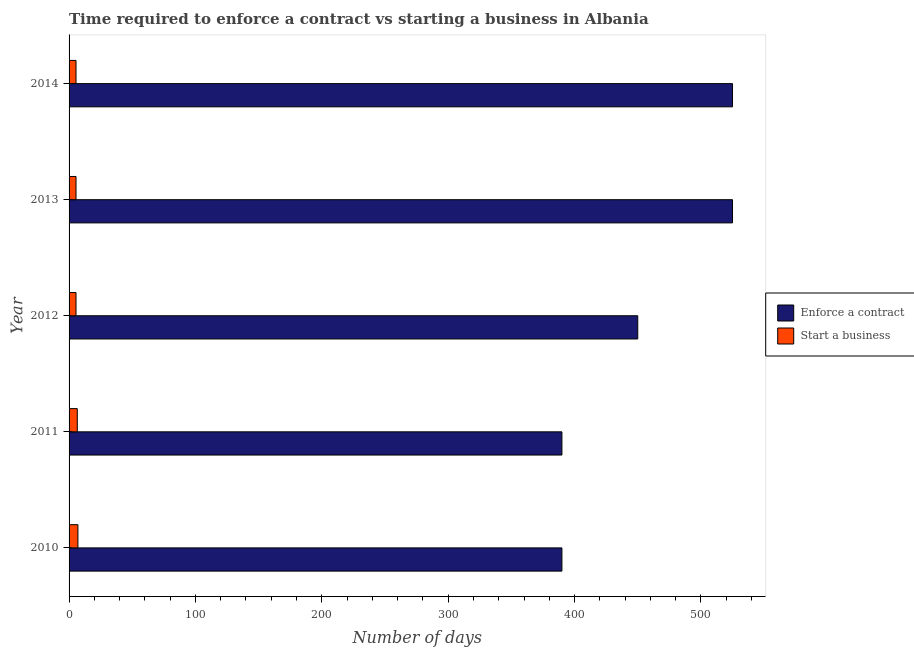How many groups of bars are there?
Provide a short and direct response. 5. Are the number of bars on each tick of the Y-axis equal?
Your response must be concise. Yes. How many bars are there on the 4th tick from the bottom?
Give a very brief answer. 2. In how many cases, is the number of bars for a given year not equal to the number of legend labels?
Your answer should be compact. 0. What is the number of days to enforece a contract in 2011?
Your response must be concise. 390. Across all years, what is the maximum number of days to enforece a contract?
Your answer should be very brief. 525. Across all years, what is the minimum number of days to enforece a contract?
Make the answer very short. 390. In which year was the number of days to enforece a contract maximum?
Offer a very short reply. 2013. What is the total number of days to enforece a contract in the graph?
Ensure brevity in your answer.  2280. What is the difference between the number of days to start a business in 2012 and that in 2014?
Keep it short and to the point. 0. What is the difference between the number of days to enforece a contract in 2010 and the number of days to start a business in 2012?
Keep it short and to the point. 384.5. What is the average number of days to enforece a contract per year?
Ensure brevity in your answer.  456. In the year 2013, what is the difference between the number of days to start a business and number of days to enforece a contract?
Give a very brief answer. -519.5. What is the ratio of the number of days to enforece a contract in 2011 to that in 2013?
Give a very brief answer. 0.74. Is the number of days to enforece a contract in 2010 less than that in 2014?
Your answer should be compact. Yes. Is the difference between the number of days to enforece a contract in 2010 and 2012 greater than the difference between the number of days to start a business in 2010 and 2012?
Provide a succinct answer. No. What is the difference between the highest and the lowest number of days to start a business?
Provide a short and direct response. 1.5. What does the 2nd bar from the top in 2012 represents?
Give a very brief answer. Enforce a contract. What does the 2nd bar from the bottom in 2010 represents?
Make the answer very short. Start a business. Are all the bars in the graph horizontal?
Make the answer very short. Yes. How many years are there in the graph?
Ensure brevity in your answer.  5. Does the graph contain grids?
Provide a succinct answer. No. How many legend labels are there?
Ensure brevity in your answer.  2. How are the legend labels stacked?
Offer a very short reply. Vertical. What is the title of the graph?
Give a very brief answer. Time required to enforce a contract vs starting a business in Albania. Does "Working capital" appear as one of the legend labels in the graph?
Ensure brevity in your answer.  No. What is the label or title of the X-axis?
Your answer should be compact. Number of days. What is the label or title of the Y-axis?
Your answer should be very brief. Year. What is the Number of days in Enforce a contract in 2010?
Your answer should be compact. 390. What is the Number of days of Enforce a contract in 2011?
Provide a succinct answer. 390. What is the Number of days in Enforce a contract in 2012?
Offer a terse response. 450. What is the Number of days of Enforce a contract in 2013?
Provide a short and direct response. 525. What is the Number of days of Start a business in 2013?
Your answer should be compact. 5.5. What is the Number of days of Enforce a contract in 2014?
Offer a very short reply. 525. Across all years, what is the maximum Number of days in Enforce a contract?
Your answer should be very brief. 525. Across all years, what is the maximum Number of days of Start a business?
Provide a succinct answer. 7. Across all years, what is the minimum Number of days of Enforce a contract?
Offer a very short reply. 390. What is the total Number of days of Enforce a contract in the graph?
Give a very brief answer. 2280. What is the total Number of days of Start a business in the graph?
Keep it short and to the point. 30. What is the difference between the Number of days of Enforce a contract in 2010 and that in 2011?
Your answer should be compact. 0. What is the difference between the Number of days of Start a business in 2010 and that in 2011?
Your answer should be very brief. 0.5. What is the difference between the Number of days in Enforce a contract in 2010 and that in 2012?
Provide a succinct answer. -60. What is the difference between the Number of days of Start a business in 2010 and that in 2012?
Your response must be concise. 1.5. What is the difference between the Number of days in Enforce a contract in 2010 and that in 2013?
Your answer should be compact. -135. What is the difference between the Number of days in Enforce a contract in 2010 and that in 2014?
Offer a very short reply. -135. What is the difference between the Number of days of Enforce a contract in 2011 and that in 2012?
Provide a short and direct response. -60. What is the difference between the Number of days in Enforce a contract in 2011 and that in 2013?
Offer a terse response. -135. What is the difference between the Number of days in Start a business in 2011 and that in 2013?
Offer a very short reply. 1. What is the difference between the Number of days of Enforce a contract in 2011 and that in 2014?
Your response must be concise. -135. What is the difference between the Number of days of Start a business in 2011 and that in 2014?
Give a very brief answer. 1. What is the difference between the Number of days in Enforce a contract in 2012 and that in 2013?
Your answer should be compact. -75. What is the difference between the Number of days in Enforce a contract in 2012 and that in 2014?
Keep it short and to the point. -75. What is the difference between the Number of days in Enforce a contract in 2010 and the Number of days in Start a business in 2011?
Your answer should be very brief. 383.5. What is the difference between the Number of days in Enforce a contract in 2010 and the Number of days in Start a business in 2012?
Give a very brief answer. 384.5. What is the difference between the Number of days of Enforce a contract in 2010 and the Number of days of Start a business in 2013?
Provide a short and direct response. 384.5. What is the difference between the Number of days of Enforce a contract in 2010 and the Number of days of Start a business in 2014?
Provide a succinct answer. 384.5. What is the difference between the Number of days in Enforce a contract in 2011 and the Number of days in Start a business in 2012?
Your response must be concise. 384.5. What is the difference between the Number of days in Enforce a contract in 2011 and the Number of days in Start a business in 2013?
Your response must be concise. 384.5. What is the difference between the Number of days in Enforce a contract in 2011 and the Number of days in Start a business in 2014?
Keep it short and to the point. 384.5. What is the difference between the Number of days of Enforce a contract in 2012 and the Number of days of Start a business in 2013?
Give a very brief answer. 444.5. What is the difference between the Number of days in Enforce a contract in 2012 and the Number of days in Start a business in 2014?
Your answer should be very brief. 444.5. What is the difference between the Number of days of Enforce a contract in 2013 and the Number of days of Start a business in 2014?
Make the answer very short. 519.5. What is the average Number of days of Enforce a contract per year?
Provide a succinct answer. 456. What is the average Number of days in Start a business per year?
Make the answer very short. 6. In the year 2010, what is the difference between the Number of days of Enforce a contract and Number of days of Start a business?
Provide a short and direct response. 383. In the year 2011, what is the difference between the Number of days of Enforce a contract and Number of days of Start a business?
Ensure brevity in your answer.  383.5. In the year 2012, what is the difference between the Number of days in Enforce a contract and Number of days in Start a business?
Give a very brief answer. 444.5. In the year 2013, what is the difference between the Number of days in Enforce a contract and Number of days in Start a business?
Provide a short and direct response. 519.5. In the year 2014, what is the difference between the Number of days of Enforce a contract and Number of days of Start a business?
Ensure brevity in your answer.  519.5. What is the ratio of the Number of days of Enforce a contract in 2010 to that in 2012?
Give a very brief answer. 0.87. What is the ratio of the Number of days in Start a business in 2010 to that in 2012?
Give a very brief answer. 1.27. What is the ratio of the Number of days in Enforce a contract in 2010 to that in 2013?
Make the answer very short. 0.74. What is the ratio of the Number of days of Start a business in 2010 to that in 2013?
Offer a terse response. 1.27. What is the ratio of the Number of days in Enforce a contract in 2010 to that in 2014?
Give a very brief answer. 0.74. What is the ratio of the Number of days in Start a business in 2010 to that in 2014?
Keep it short and to the point. 1.27. What is the ratio of the Number of days of Enforce a contract in 2011 to that in 2012?
Provide a short and direct response. 0.87. What is the ratio of the Number of days of Start a business in 2011 to that in 2012?
Make the answer very short. 1.18. What is the ratio of the Number of days of Enforce a contract in 2011 to that in 2013?
Your answer should be compact. 0.74. What is the ratio of the Number of days in Start a business in 2011 to that in 2013?
Offer a very short reply. 1.18. What is the ratio of the Number of days in Enforce a contract in 2011 to that in 2014?
Offer a terse response. 0.74. What is the ratio of the Number of days in Start a business in 2011 to that in 2014?
Your answer should be very brief. 1.18. What is the ratio of the Number of days in Start a business in 2012 to that in 2014?
Provide a succinct answer. 1. What is the ratio of the Number of days of Enforce a contract in 2013 to that in 2014?
Make the answer very short. 1. What is the difference between the highest and the second highest Number of days of Enforce a contract?
Your answer should be compact. 0. What is the difference between the highest and the second highest Number of days in Start a business?
Your response must be concise. 0.5. What is the difference between the highest and the lowest Number of days of Enforce a contract?
Keep it short and to the point. 135. 